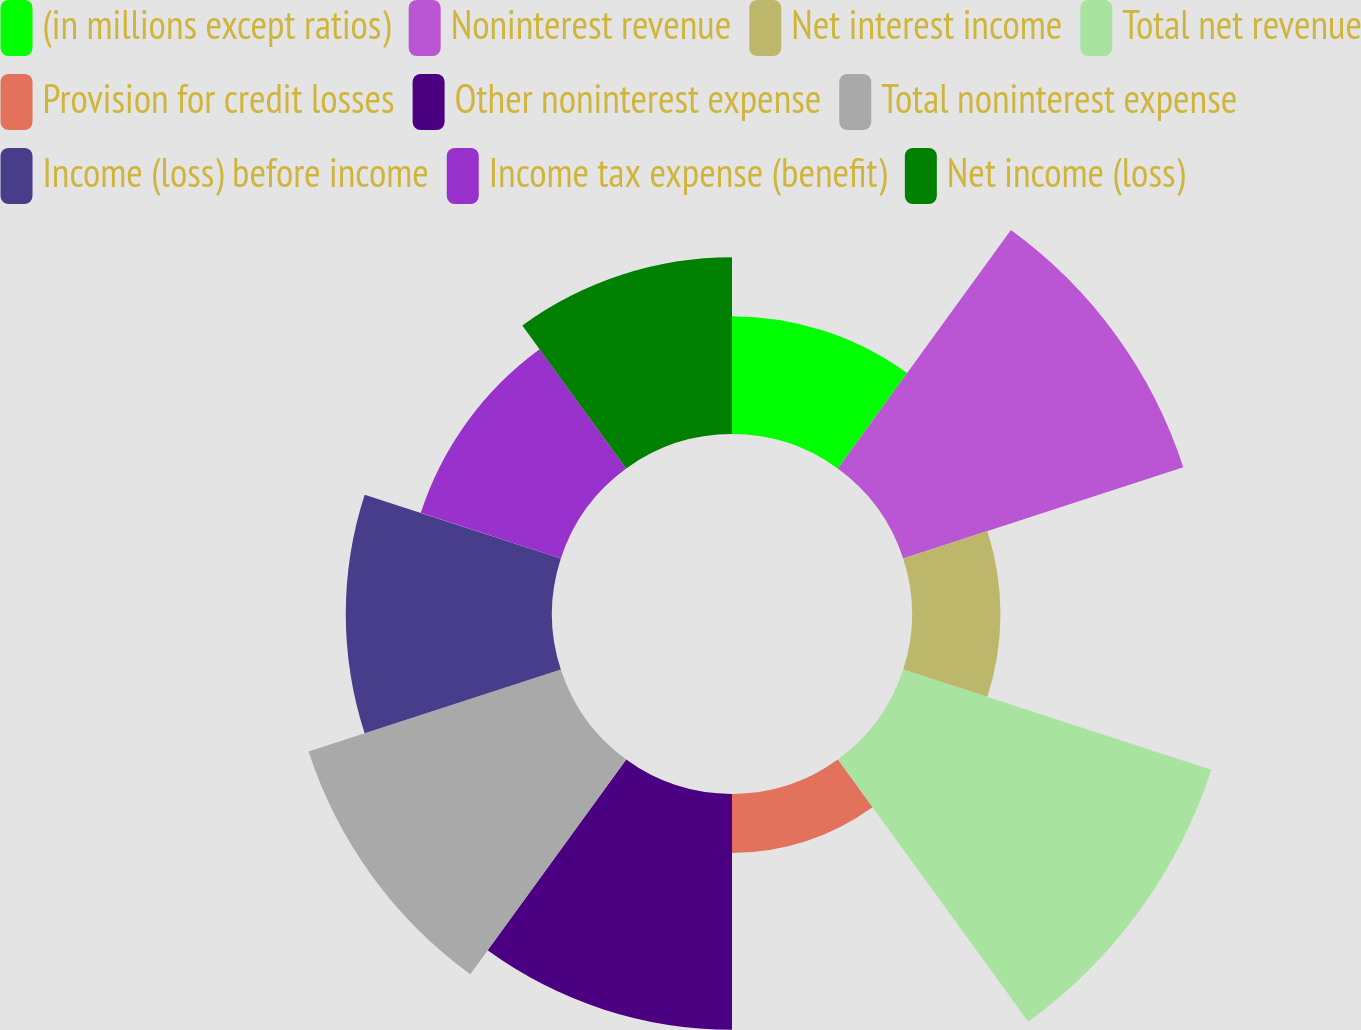Convert chart to OTSL. <chart><loc_0><loc_0><loc_500><loc_500><pie_chart><fcel>(in millions except ratios)<fcel>Noninterest revenue<fcel>Net interest income<fcel>Total net revenue<fcel>Provision for credit losses<fcel>Other noninterest expense<fcel>Total noninterest expense<fcel>Income (loss) before income<fcel>Income tax expense (benefit)<fcel>Net income (loss)<nl><fcel>6.15%<fcel>15.38%<fcel>4.62%<fcel>16.92%<fcel>3.08%<fcel>12.31%<fcel>13.85%<fcel>10.77%<fcel>7.69%<fcel>9.23%<nl></chart> 